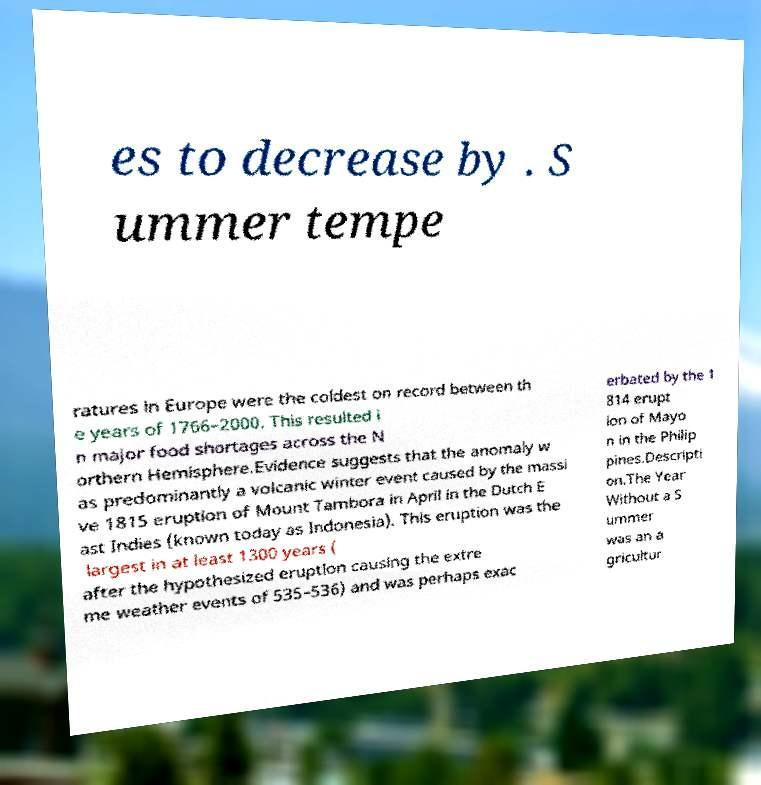I need the written content from this picture converted into text. Can you do that? es to decrease by . S ummer tempe ratures in Europe were the coldest on record between th e years of 1766–2000. This resulted i n major food shortages across the N orthern Hemisphere.Evidence suggests that the anomaly w as predominantly a volcanic winter event caused by the massi ve 1815 eruption of Mount Tambora in April in the Dutch E ast Indies (known today as Indonesia). This eruption was the largest in at least 1300 years ( after the hypothesized eruption causing the extre me weather events of 535–536) and was perhaps exac erbated by the 1 814 erupt ion of Mayo n in the Philip pines.Descripti on.The Year Without a S ummer was an a gricultur 